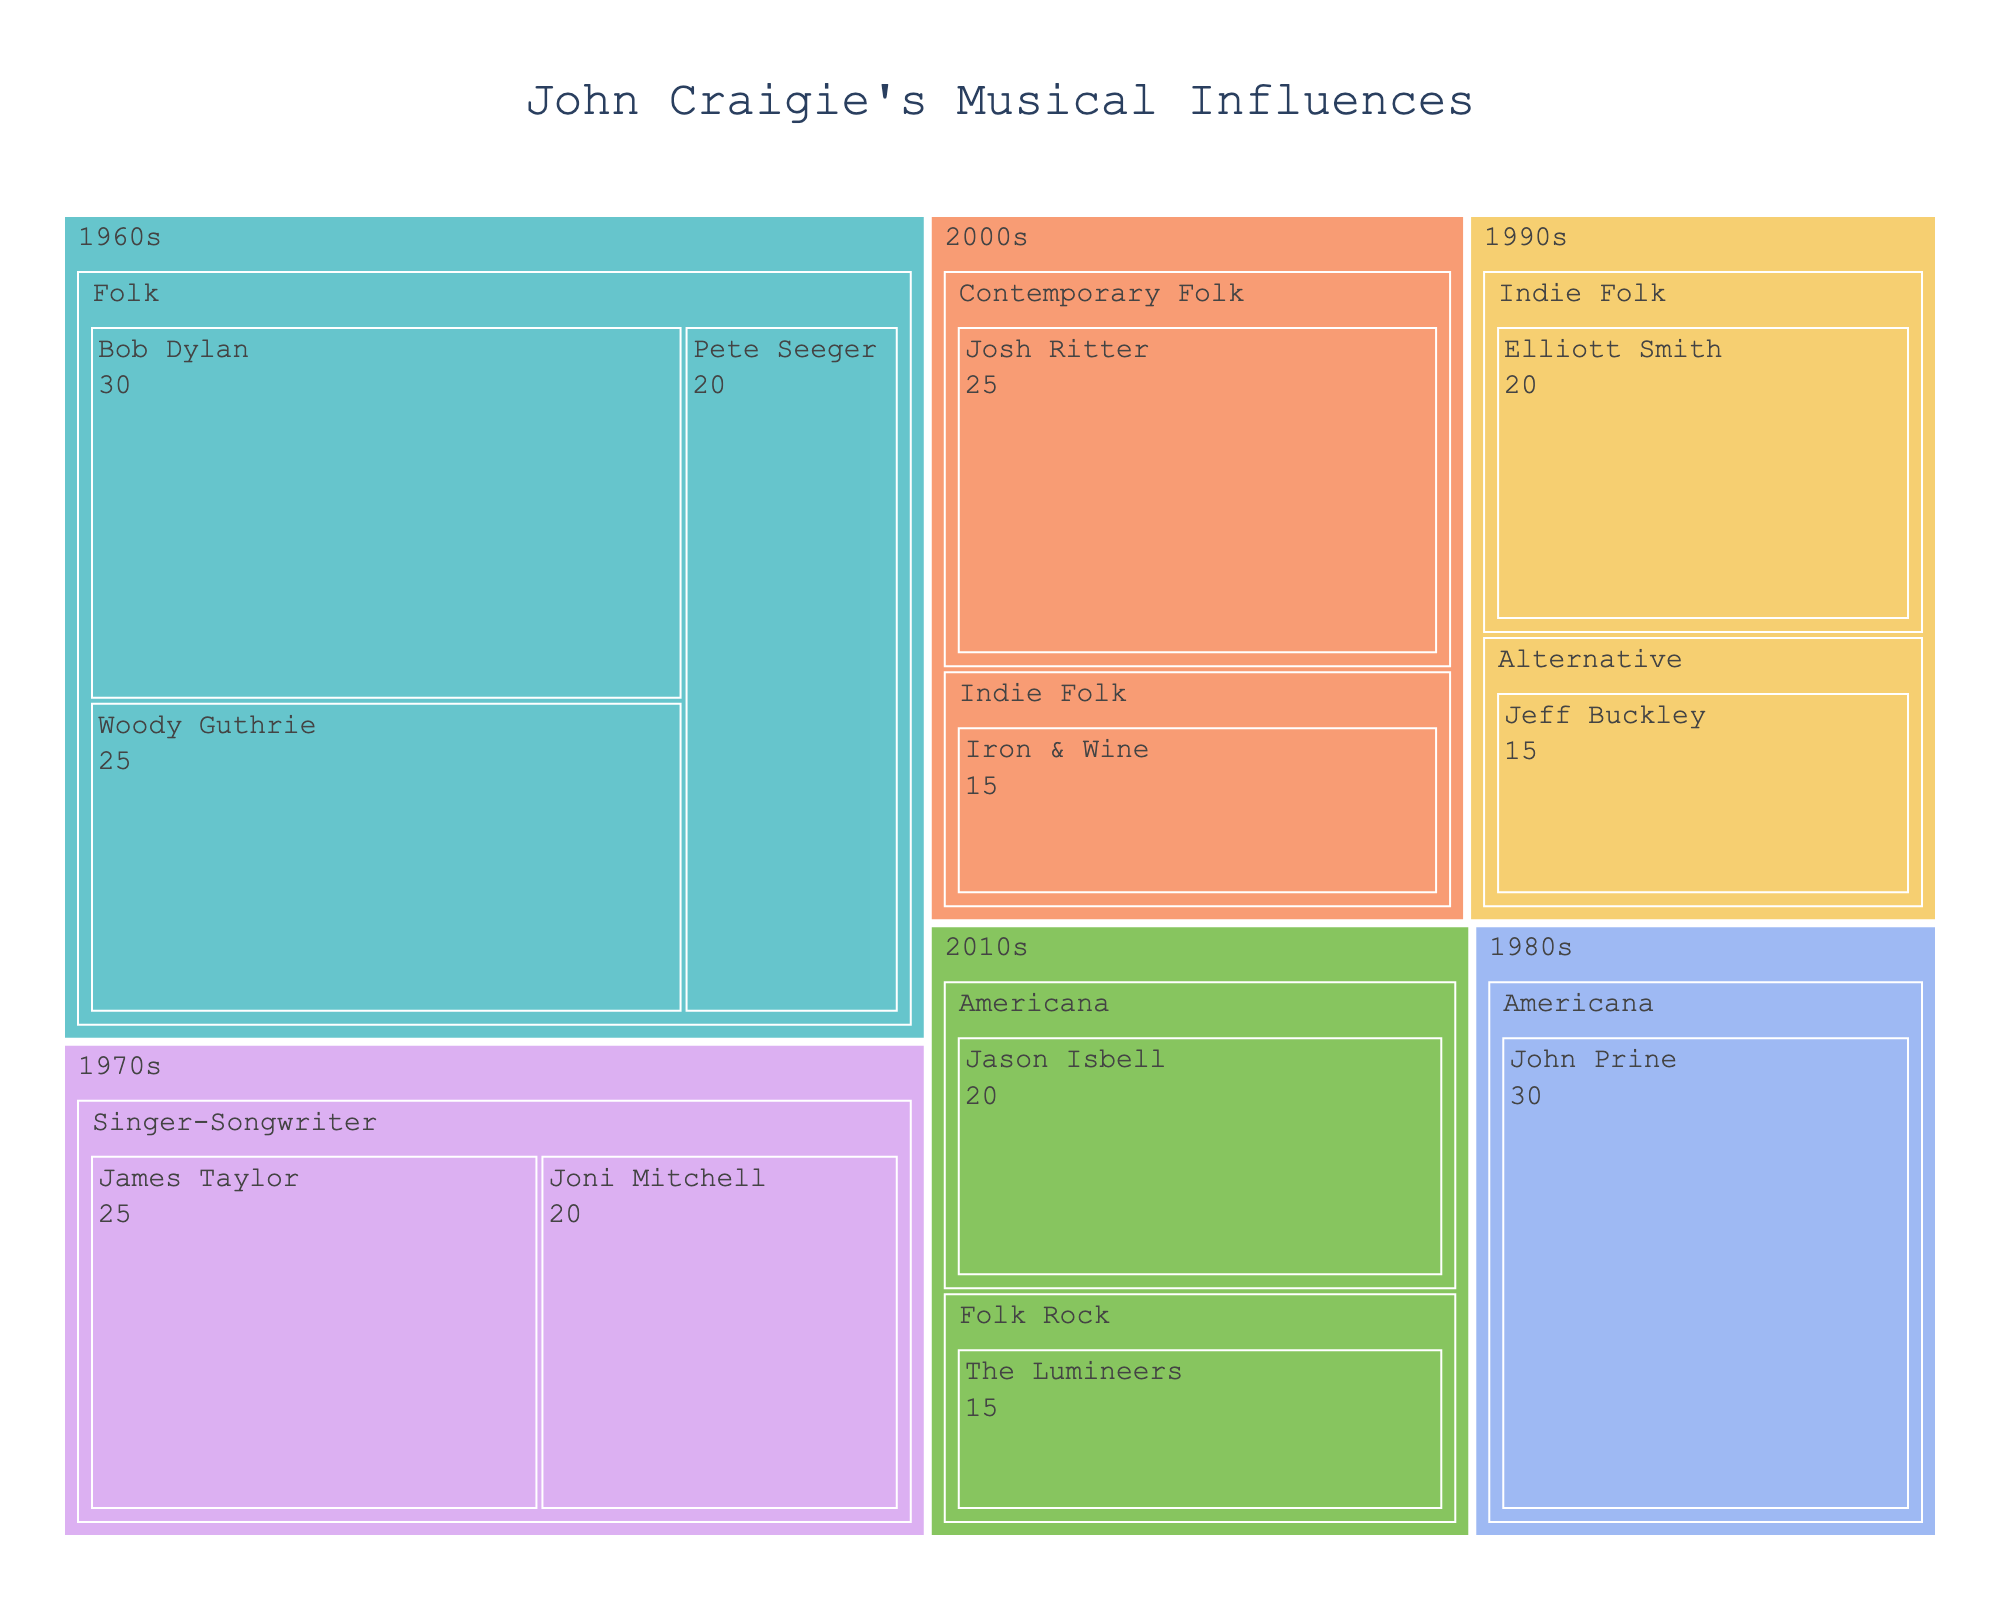What is the title of the Treemap? The title is often placed at the top of a chart. By looking at the visual, we can identify the title directly.
Answer: John Craigie's Musical Influences Which musical influence from the 1960s has the highest value? Navigate to the 1960s section and compare the values within that era. Bob Dylan has the highest value in the 1960s.
Answer: Bob Dylan What is the sum of the value of influences from the 2010s? Identify and sum all values from the 2010s. Jason Isbell (20) + The Lumineers (15) = 35
Answer: 35 Which era has the most influences listed? Count the number of influences in each era and compare. The 1960s has the most influences listed with three: Bob Dylan, Woody Guthrie, and Pete Seeger.
Answer: 1960s Compare the influence value of James Taylor with Joni Mitchell. Who has more? Locate James Taylor and Joni Mitchell in the 1970s section, then compare their values. James Taylor has a value of 25 while Joni Mitchell has 20.
Answer: James Taylor What genres are represented in the 2000s? Look under the 2000s section and note the genres listed. The genres are Contemporary Folk and Indie Folk.
Answer: Contemporary Folk, Indie Folk How does the influence value of John Prine compare to that of Jason Isbell? Locate John Prine in the 1980s section and Jason Isbell in the 2010s section. John Prine has a value of 30, whereas Jason Isbell has 20.
Answer: John Prine has 10 more than Jason Isbell What is the average value of influences in the Folk genre? Locate all influences within the Folk genre and calculate their average. Values are Bob Dylan (30), Woody Guthrie (25), and Pete Seeger (20). The average is (30 + 25 + 20) / 3 = 75 / 3 = 25
Answer: 25 Which genre in the 2010s has a lower influence value? Identify the genres from the 2010s and compare. Folk Rock has a value of 15, and Americana has a value of 20. Folk Rock is lower.
Answer: Folk Rock How many unique genres are represented in total? Identify and count the unique genres listed throughout all eras. The unique genres are Folk, Singer-Songwriter, Americana, Alternative, Indie Folk, Contemporary Folk, and Folk Rock.
Answer: 7 